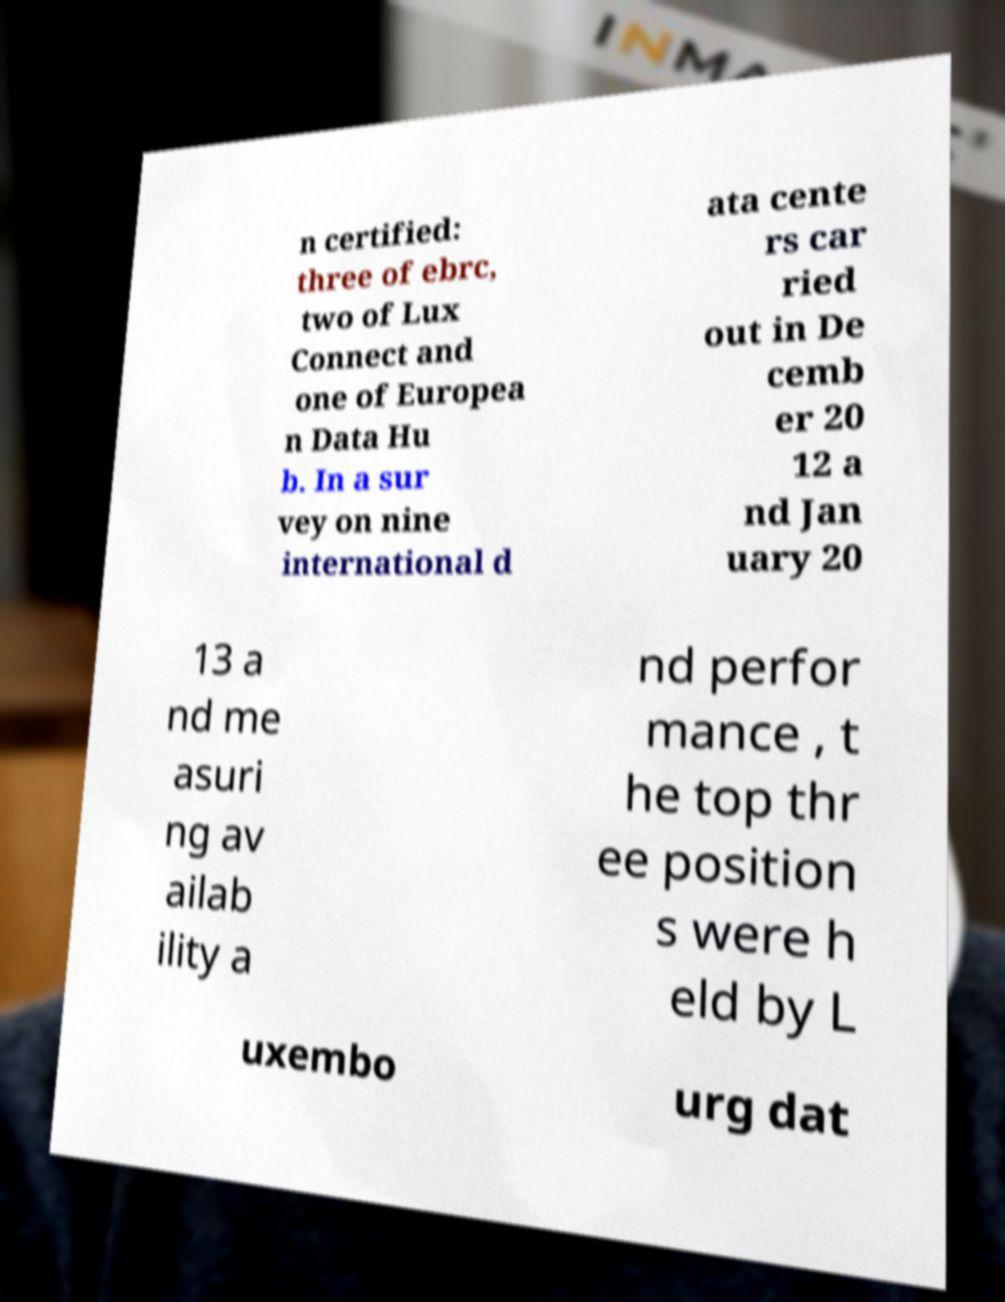Please identify and transcribe the text found in this image. n certified: three of ebrc, two of Lux Connect and one of Europea n Data Hu b. In a sur vey on nine international d ata cente rs car ried out in De cemb er 20 12 a nd Jan uary 20 13 a nd me asuri ng av ailab ility a nd perfor mance , t he top thr ee position s were h eld by L uxembo urg dat 